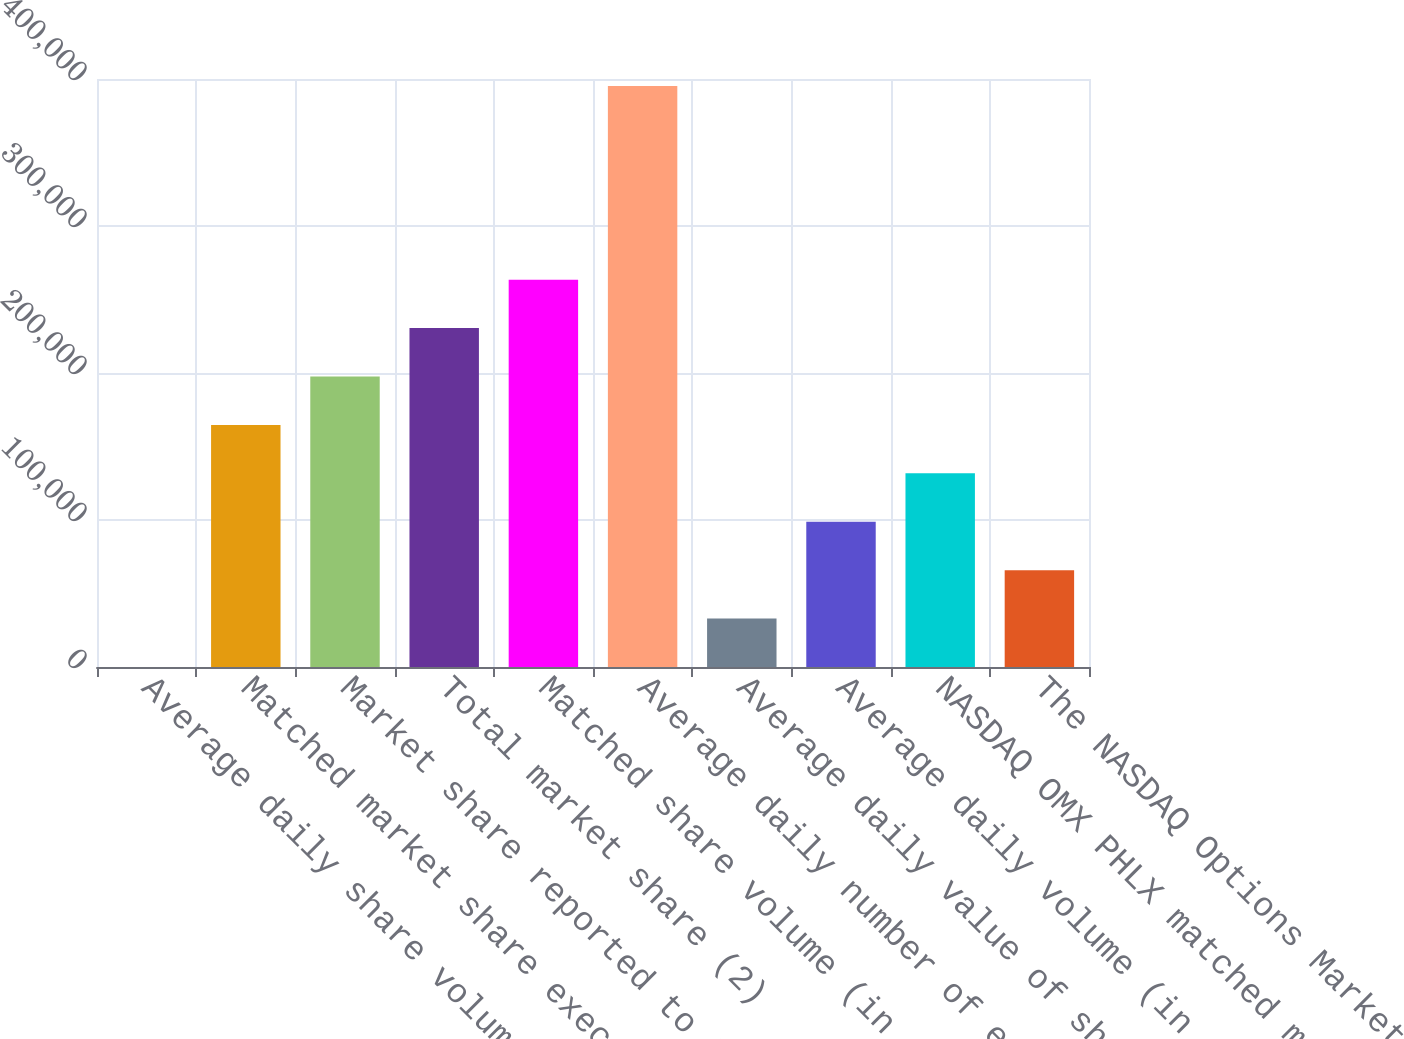Convert chart to OTSL. <chart><loc_0><loc_0><loc_500><loc_500><bar_chart><fcel>Average daily share volume (in<fcel>Matched market share executed<fcel>Market share reported to the<fcel>Total market share (2)<fcel>Matched share volume (in<fcel>Average daily number of equity<fcel>Average daily value of shares<fcel>Average daily volume (in<fcel>NASDAQ OMX PHLX matched market<fcel>The NASDAQ Options Market<nl><fcel>2.24<fcel>164676<fcel>197611<fcel>230546<fcel>263480<fcel>395220<fcel>32937<fcel>98806.6<fcel>131741<fcel>65871.8<nl></chart> 